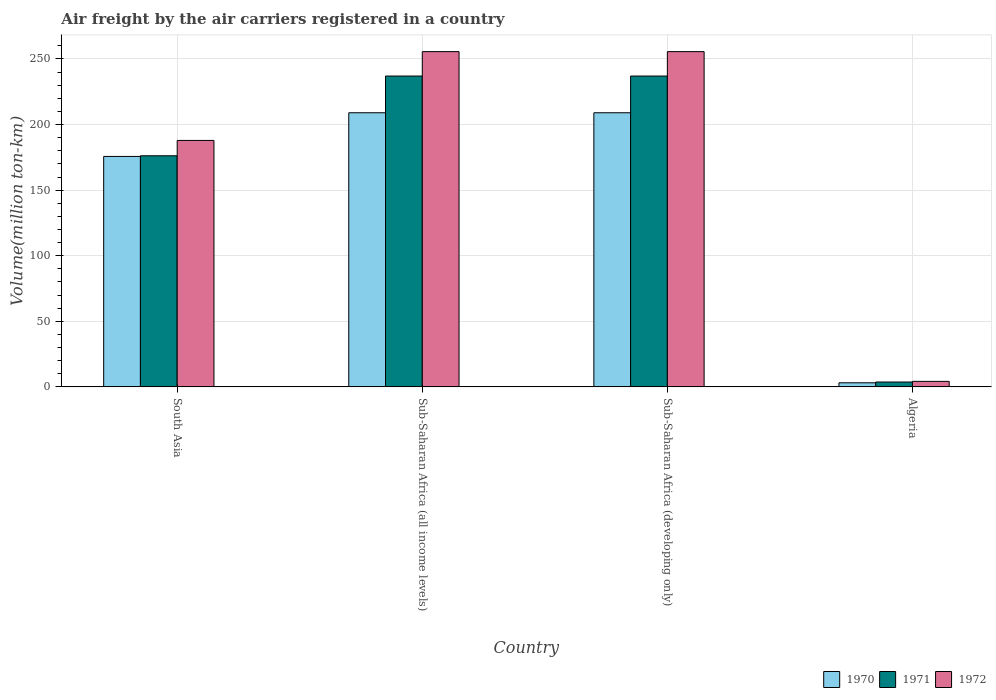How many different coloured bars are there?
Provide a succinct answer. 3. Are the number of bars per tick equal to the number of legend labels?
Your answer should be compact. Yes. Are the number of bars on each tick of the X-axis equal?
Your response must be concise. Yes. How many bars are there on the 3rd tick from the left?
Your answer should be very brief. 3. How many bars are there on the 4th tick from the right?
Offer a terse response. 3. What is the label of the 2nd group of bars from the left?
Ensure brevity in your answer.  Sub-Saharan Africa (all income levels). In how many cases, is the number of bars for a given country not equal to the number of legend labels?
Your answer should be very brief. 0. What is the volume of the air carriers in 1970 in Sub-Saharan Africa (developing only)?
Ensure brevity in your answer.  209. Across all countries, what is the maximum volume of the air carriers in 1971?
Give a very brief answer. 237. Across all countries, what is the minimum volume of the air carriers in 1970?
Make the answer very short. 3.1. In which country was the volume of the air carriers in 1971 maximum?
Make the answer very short. Sub-Saharan Africa (all income levels). In which country was the volume of the air carriers in 1970 minimum?
Give a very brief answer. Algeria. What is the total volume of the air carriers in 1970 in the graph?
Give a very brief answer. 596.8. What is the difference between the volume of the air carriers in 1971 in South Asia and that in Sub-Saharan Africa (all income levels)?
Your answer should be very brief. -60.8. What is the difference between the volume of the air carriers in 1970 in Sub-Saharan Africa (all income levels) and the volume of the air carriers in 1972 in Sub-Saharan Africa (developing only)?
Your answer should be very brief. -46.6. What is the average volume of the air carriers in 1971 per country?
Offer a terse response. 163.48. What is the difference between the volume of the air carriers of/in 1970 and volume of the air carriers of/in 1971 in Algeria?
Your response must be concise. -0.6. What is the ratio of the volume of the air carriers in 1971 in Algeria to that in Sub-Saharan Africa (developing only)?
Ensure brevity in your answer.  0.02. Is the volume of the air carriers in 1971 in South Asia less than that in Sub-Saharan Africa (developing only)?
Provide a succinct answer. Yes. Is the difference between the volume of the air carriers in 1970 in South Asia and Sub-Saharan Africa (developing only) greater than the difference between the volume of the air carriers in 1971 in South Asia and Sub-Saharan Africa (developing only)?
Offer a terse response. Yes. What is the difference between the highest and the second highest volume of the air carriers in 1971?
Ensure brevity in your answer.  -60.8. What is the difference between the highest and the lowest volume of the air carriers in 1970?
Ensure brevity in your answer.  205.9. In how many countries, is the volume of the air carriers in 1970 greater than the average volume of the air carriers in 1970 taken over all countries?
Your answer should be compact. 3. What does the 3rd bar from the left in Sub-Saharan Africa (developing only) represents?
Keep it short and to the point. 1972. Is it the case that in every country, the sum of the volume of the air carriers in 1972 and volume of the air carriers in 1970 is greater than the volume of the air carriers in 1971?
Offer a very short reply. Yes. How many bars are there?
Give a very brief answer. 12. How many countries are there in the graph?
Offer a very short reply. 4. Does the graph contain any zero values?
Make the answer very short. No. Does the graph contain grids?
Provide a succinct answer. Yes. What is the title of the graph?
Offer a very short reply. Air freight by the air carriers registered in a country. Does "1975" appear as one of the legend labels in the graph?
Make the answer very short. No. What is the label or title of the X-axis?
Make the answer very short. Country. What is the label or title of the Y-axis?
Your response must be concise. Volume(million ton-km). What is the Volume(million ton-km) in 1970 in South Asia?
Your response must be concise. 175.7. What is the Volume(million ton-km) in 1971 in South Asia?
Give a very brief answer. 176.2. What is the Volume(million ton-km) of 1972 in South Asia?
Keep it short and to the point. 187.9. What is the Volume(million ton-km) of 1970 in Sub-Saharan Africa (all income levels)?
Offer a terse response. 209. What is the Volume(million ton-km) of 1971 in Sub-Saharan Africa (all income levels)?
Give a very brief answer. 237. What is the Volume(million ton-km) of 1972 in Sub-Saharan Africa (all income levels)?
Provide a succinct answer. 255.6. What is the Volume(million ton-km) in 1970 in Sub-Saharan Africa (developing only)?
Ensure brevity in your answer.  209. What is the Volume(million ton-km) in 1971 in Sub-Saharan Africa (developing only)?
Your answer should be compact. 237. What is the Volume(million ton-km) in 1972 in Sub-Saharan Africa (developing only)?
Provide a succinct answer. 255.6. What is the Volume(million ton-km) of 1970 in Algeria?
Give a very brief answer. 3.1. What is the Volume(million ton-km) of 1971 in Algeria?
Provide a short and direct response. 3.7. What is the Volume(million ton-km) in 1972 in Algeria?
Offer a terse response. 4.2. Across all countries, what is the maximum Volume(million ton-km) of 1970?
Make the answer very short. 209. Across all countries, what is the maximum Volume(million ton-km) in 1971?
Your answer should be very brief. 237. Across all countries, what is the maximum Volume(million ton-km) of 1972?
Offer a terse response. 255.6. Across all countries, what is the minimum Volume(million ton-km) in 1970?
Your answer should be very brief. 3.1. Across all countries, what is the minimum Volume(million ton-km) in 1971?
Give a very brief answer. 3.7. Across all countries, what is the minimum Volume(million ton-km) of 1972?
Your answer should be compact. 4.2. What is the total Volume(million ton-km) in 1970 in the graph?
Your response must be concise. 596.8. What is the total Volume(million ton-km) in 1971 in the graph?
Your answer should be very brief. 653.9. What is the total Volume(million ton-km) in 1972 in the graph?
Offer a terse response. 703.3. What is the difference between the Volume(million ton-km) in 1970 in South Asia and that in Sub-Saharan Africa (all income levels)?
Ensure brevity in your answer.  -33.3. What is the difference between the Volume(million ton-km) of 1971 in South Asia and that in Sub-Saharan Africa (all income levels)?
Your answer should be very brief. -60.8. What is the difference between the Volume(million ton-km) of 1972 in South Asia and that in Sub-Saharan Africa (all income levels)?
Keep it short and to the point. -67.7. What is the difference between the Volume(million ton-km) of 1970 in South Asia and that in Sub-Saharan Africa (developing only)?
Keep it short and to the point. -33.3. What is the difference between the Volume(million ton-km) of 1971 in South Asia and that in Sub-Saharan Africa (developing only)?
Make the answer very short. -60.8. What is the difference between the Volume(million ton-km) in 1972 in South Asia and that in Sub-Saharan Africa (developing only)?
Offer a terse response. -67.7. What is the difference between the Volume(million ton-km) of 1970 in South Asia and that in Algeria?
Your response must be concise. 172.6. What is the difference between the Volume(million ton-km) of 1971 in South Asia and that in Algeria?
Your answer should be compact. 172.5. What is the difference between the Volume(million ton-km) of 1972 in South Asia and that in Algeria?
Provide a short and direct response. 183.7. What is the difference between the Volume(million ton-km) in 1972 in Sub-Saharan Africa (all income levels) and that in Sub-Saharan Africa (developing only)?
Your answer should be very brief. 0. What is the difference between the Volume(million ton-km) in 1970 in Sub-Saharan Africa (all income levels) and that in Algeria?
Keep it short and to the point. 205.9. What is the difference between the Volume(million ton-km) in 1971 in Sub-Saharan Africa (all income levels) and that in Algeria?
Keep it short and to the point. 233.3. What is the difference between the Volume(million ton-km) in 1972 in Sub-Saharan Africa (all income levels) and that in Algeria?
Give a very brief answer. 251.4. What is the difference between the Volume(million ton-km) of 1970 in Sub-Saharan Africa (developing only) and that in Algeria?
Ensure brevity in your answer.  205.9. What is the difference between the Volume(million ton-km) in 1971 in Sub-Saharan Africa (developing only) and that in Algeria?
Offer a terse response. 233.3. What is the difference between the Volume(million ton-km) in 1972 in Sub-Saharan Africa (developing only) and that in Algeria?
Provide a succinct answer. 251.4. What is the difference between the Volume(million ton-km) of 1970 in South Asia and the Volume(million ton-km) of 1971 in Sub-Saharan Africa (all income levels)?
Keep it short and to the point. -61.3. What is the difference between the Volume(million ton-km) in 1970 in South Asia and the Volume(million ton-km) in 1972 in Sub-Saharan Africa (all income levels)?
Offer a very short reply. -79.9. What is the difference between the Volume(million ton-km) of 1971 in South Asia and the Volume(million ton-km) of 1972 in Sub-Saharan Africa (all income levels)?
Provide a short and direct response. -79.4. What is the difference between the Volume(million ton-km) in 1970 in South Asia and the Volume(million ton-km) in 1971 in Sub-Saharan Africa (developing only)?
Give a very brief answer. -61.3. What is the difference between the Volume(million ton-km) of 1970 in South Asia and the Volume(million ton-km) of 1972 in Sub-Saharan Africa (developing only)?
Provide a succinct answer. -79.9. What is the difference between the Volume(million ton-km) in 1971 in South Asia and the Volume(million ton-km) in 1972 in Sub-Saharan Africa (developing only)?
Make the answer very short. -79.4. What is the difference between the Volume(million ton-km) of 1970 in South Asia and the Volume(million ton-km) of 1971 in Algeria?
Your response must be concise. 172. What is the difference between the Volume(million ton-km) of 1970 in South Asia and the Volume(million ton-km) of 1972 in Algeria?
Give a very brief answer. 171.5. What is the difference between the Volume(million ton-km) of 1971 in South Asia and the Volume(million ton-km) of 1972 in Algeria?
Provide a short and direct response. 172. What is the difference between the Volume(million ton-km) in 1970 in Sub-Saharan Africa (all income levels) and the Volume(million ton-km) in 1971 in Sub-Saharan Africa (developing only)?
Your answer should be compact. -28. What is the difference between the Volume(million ton-km) of 1970 in Sub-Saharan Africa (all income levels) and the Volume(million ton-km) of 1972 in Sub-Saharan Africa (developing only)?
Offer a terse response. -46.6. What is the difference between the Volume(million ton-km) in 1971 in Sub-Saharan Africa (all income levels) and the Volume(million ton-km) in 1972 in Sub-Saharan Africa (developing only)?
Ensure brevity in your answer.  -18.6. What is the difference between the Volume(million ton-km) of 1970 in Sub-Saharan Africa (all income levels) and the Volume(million ton-km) of 1971 in Algeria?
Ensure brevity in your answer.  205.3. What is the difference between the Volume(million ton-km) in 1970 in Sub-Saharan Africa (all income levels) and the Volume(million ton-km) in 1972 in Algeria?
Offer a terse response. 204.8. What is the difference between the Volume(million ton-km) in 1971 in Sub-Saharan Africa (all income levels) and the Volume(million ton-km) in 1972 in Algeria?
Your response must be concise. 232.8. What is the difference between the Volume(million ton-km) in 1970 in Sub-Saharan Africa (developing only) and the Volume(million ton-km) in 1971 in Algeria?
Give a very brief answer. 205.3. What is the difference between the Volume(million ton-km) of 1970 in Sub-Saharan Africa (developing only) and the Volume(million ton-km) of 1972 in Algeria?
Provide a short and direct response. 204.8. What is the difference between the Volume(million ton-km) in 1971 in Sub-Saharan Africa (developing only) and the Volume(million ton-km) in 1972 in Algeria?
Offer a very short reply. 232.8. What is the average Volume(million ton-km) of 1970 per country?
Your response must be concise. 149.2. What is the average Volume(million ton-km) in 1971 per country?
Ensure brevity in your answer.  163.47. What is the average Volume(million ton-km) of 1972 per country?
Ensure brevity in your answer.  175.82. What is the difference between the Volume(million ton-km) in 1970 and Volume(million ton-km) in 1971 in South Asia?
Your answer should be very brief. -0.5. What is the difference between the Volume(million ton-km) in 1970 and Volume(million ton-km) in 1972 in Sub-Saharan Africa (all income levels)?
Offer a terse response. -46.6. What is the difference between the Volume(million ton-km) in 1971 and Volume(million ton-km) in 1972 in Sub-Saharan Africa (all income levels)?
Offer a terse response. -18.6. What is the difference between the Volume(million ton-km) of 1970 and Volume(million ton-km) of 1971 in Sub-Saharan Africa (developing only)?
Make the answer very short. -28. What is the difference between the Volume(million ton-km) of 1970 and Volume(million ton-km) of 1972 in Sub-Saharan Africa (developing only)?
Make the answer very short. -46.6. What is the difference between the Volume(million ton-km) in 1971 and Volume(million ton-km) in 1972 in Sub-Saharan Africa (developing only)?
Your answer should be compact. -18.6. What is the difference between the Volume(million ton-km) of 1970 and Volume(million ton-km) of 1972 in Algeria?
Offer a very short reply. -1.1. What is the ratio of the Volume(million ton-km) of 1970 in South Asia to that in Sub-Saharan Africa (all income levels)?
Your answer should be very brief. 0.84. What is the ratio of the Volume(million ton-km) of 1971 in South Asia to that in Sub-Saharan Africa (all income levels)?
Keep it short and to the point. 0.74. What is the ratio of the Volume(million ton-km) of 1972 in South Asia to that in Sub-Saharan Africa (all income levels)?
Your response must be concise. 0.74. What is the ratio of the Volume(million ton-km) in 1970 in South Asia to that in Sub-Saharan Africa (developing only)?
Keep it short and to the point. 0.84. What is the ratio of the Volume(million ton-km) of 1971 in South Asia to that in Sub-Saharan Africa (developing only)?
Keep it short and to the point. 0.74. What is the ratio of the Volume(million ton-km) in 1972 in South Asia to that in Sub-Saharan Africa (developing only)?
Your answer should be very brief. 0.74. What is the ratio of the Volume(million ton-km) of 1970 in South Asia to that in Algeria?
Provide a short and direct response. 56.68. What is the ratio of the Volume(million ton-km) in 1971 in South Asia to that in Algeria?
Your answer should be very brief. 47.62. What is the ratio of the Volume(million ton-km) in 1972 in South Asia to that in Algeria?
Your answer should be very brief. 44.74. What is the ratio of the Volume(million ton-km) in 1970 in Sub-Saharan Africa (all income levels) to that in Algeria?
Give a very brief answer. 67.42. What is the ratio of the Volume(million ton-km) of 1971 in Sub-Saharan Africa (all income levels) to that in Algeria?
Your response must be concise. 64.05. What is the ratio of the Volume(million ton-km) of 1972 in Sub-Saharan Africa (all income levels) to that in Algeria?
Your answer should be compact. 60.86. What is the ratio of the Volume(million ton-km) of 1970 in Sub-Saharan Africa (developing only) to that in Algeria?
Your answer should be compact. 67.42. What is the ratio of the Volume(million ton-km) of 1971 in Sub-Saharan Africa (developing only) to that in Algeria?
Provide a succinct answer. 64.05. What is the ratio of the Volume(million ton-km) in 1972 in Sub-Saharan Africa (developing only) to that in Algeria?
Ensure brevity in your answer.  60.86. What is the difference between the highest and the second highest Volume(million ton-km) of 1970?
Your response must be concise. 0. What is the difference between the highest and the lowest Volume(million ton-km) in 1970?
Your response must be concise. 205.9. What is the difference between the highest and the lowest Volume(million ton-km) of 1971?
Keep it short and to the point. 233.3. What is the difference between the highest and the lowest Volume(million ton-km) in 1972?
Provide a succinct answer. 251.4. 